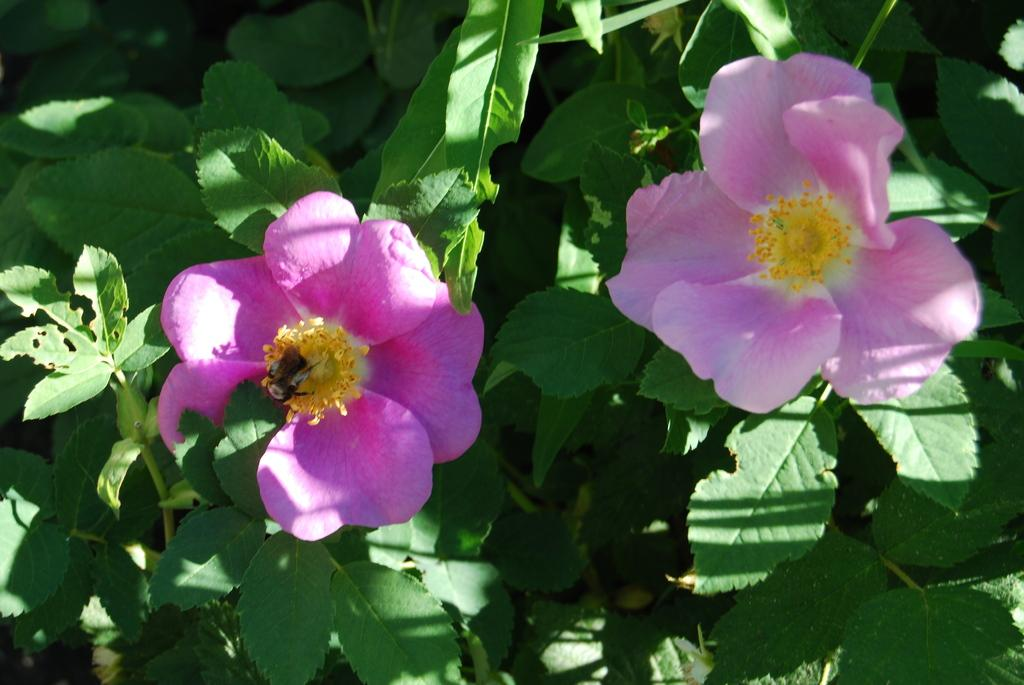What type of living organism can be seen in the image? There is a plant in the image. How many flowers are present on the plant? There are two flowers in the image. What color are the flowers? The flowers are pink in color. How many books are stacked on the orange in the image? There are no books or oranges present in the image; it only features a plant with two pink flowers. 